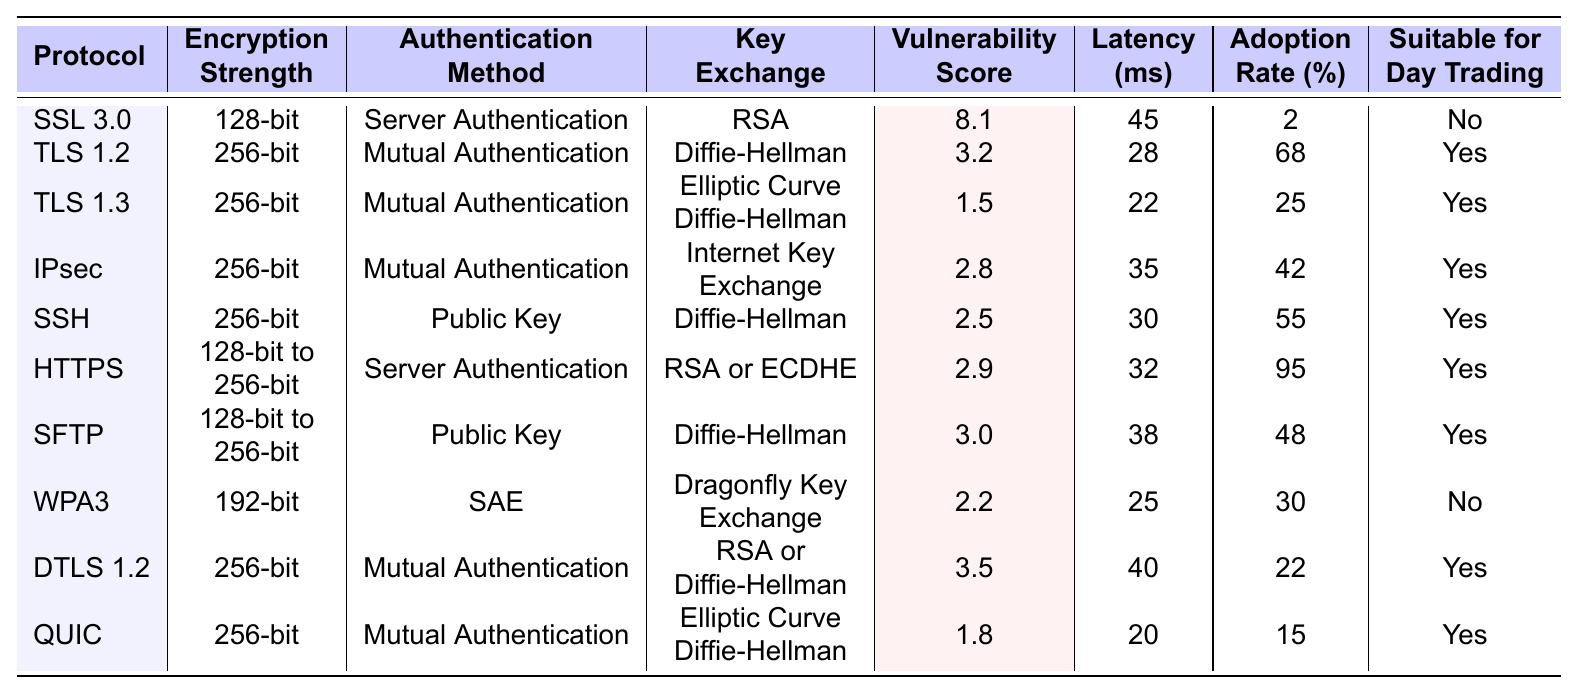What is the encryption strength of TLS 1.2? According to the table, TLS 1.2 has an encryption strength of 256-bit.
Answer: 256-bit Which protocol has the lowest vulnerability score? The vulnerability scores are: SSL 3.0 (8.1), TLS 1.2 (3.2), TLS 1.3 (1.5), IPsec (2.8), SSH (2.5), HTTPS (2.9), SFTP (3.0), WPA3 (2.2), DTLS 1.2 (3.5), QUIC (1.8). The lowest score is 1.5 for TLS 1.3.
Answer: TLS 1.3 Is HTTPS suitable for day trading? The table indicates that HTTPS has a "Yes" under "Suitable for Day Trading."
Answer: Yes What is the average latency of the protocols suitable for day trading? The latencies for suitable protocols (TLS 1.2, TLS 1.3, IPsec, SSH, HTTPS, SFTP, DTLS 1.2, QUIC) are 28, 22, 35, 30, 32, 38, 40, and 20 ms respectively. The sum is 28 + 22 + 35 + 30 + 32 + 38 + 40 + 20 = 245, and there are 8 protocols, so the average latency is 245/8 = 30.625 ms.
Answer: 30.625 ms Which protocol has the highest adoption rate and is suitable for day trading? The table shows the adoption rates: TLS 1.2 (68%), TLS 1.3 (25%), IPsec (42%), SSH (55%), HTTPS (95%), SFTP (48%), DTLS 1.2 (22%), and QUIC (15%). The highest adoption rate is 95% for HTTPS.
Answer: HTTPS How many protocols have an encryption strength of 256-bit? The protocols with 256-bit encryption are TLS 1.2, TLS 1.3, IPsec, SSH, DTLS 1.2, and QUIC. Counting them gives us 6 protocols.
Answer: 6 What is the difference in vulnerability scores between the most and least secure protocols? The most secure protocol, TLS 1.3, has a vulnerability score of 1.5, while the least secure, SSL 3.0, has a score of 8.1. The difference is 8.1 - 1.5 = 6.6.
Answer: 6.6 Which protocol has the highest latency suitable for day trading? The latencies for suitable protocols are as follows: TLS 1.2 (28 ms), TLS 1.3 (22 ms), IPsec (35 ms), SSH (30 ms), HTTPS (32 ms), SFTP (38 ms), DTLS 1.2 (40 ms), QUIC (20 ms). The highest latency among these is 40 ms for DTLS 1.2.
Answer: DTLS 1.2 Is there a protocol with a vulnerability score lower than 2.0 and also suitable for day trading? From the table, the only protocols with a vulnerability score lower than 2.0 are TLS 1.3 (1.5) and QUIC (1.8), both of which are suitable for day trading. Therefore, yes, there are protocols meeting these criteria.
Answer: Yes What is the median latency of all the protocols listed in the table? First, we list the latencies in ascending order: 20, 22, 25, 28, 30, 32, 35, 38, 40, 45. The median is the average of the 5th and 6th values (30 ms and 32 ms), which results in (30 + 32) / 2 = 31 ms.
Answer: 31 ms How many protocols have mutual authentication as their authentication method? The protocols with mutual authentication are TLS 1.2, TLS 1.3, IPsec, DTLS 1.2, and QUIC. This gives a total of 5 protocols.
Answer: 5 